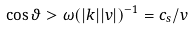Convert formula to latex. <formula><loc_0><loc_0><loc_500><loc_500>\cos \vartheta > \omega ( | { k } | | { v } | ) ^ { - 1 } = c _ { s } / v</formula> 